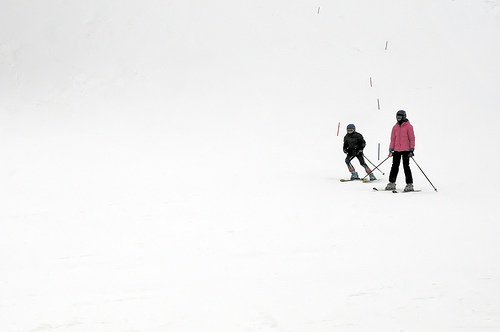Describe the objects in this image and their specific colors. I can see people in lightgray, black, brown, and gray tones, people in lightgray, black, gray, white, and darkgray tones, skis in lightgray, gray, darkgray, and tan tones, and skis in black, darkgray, gray, and lightgray tones in this image. 